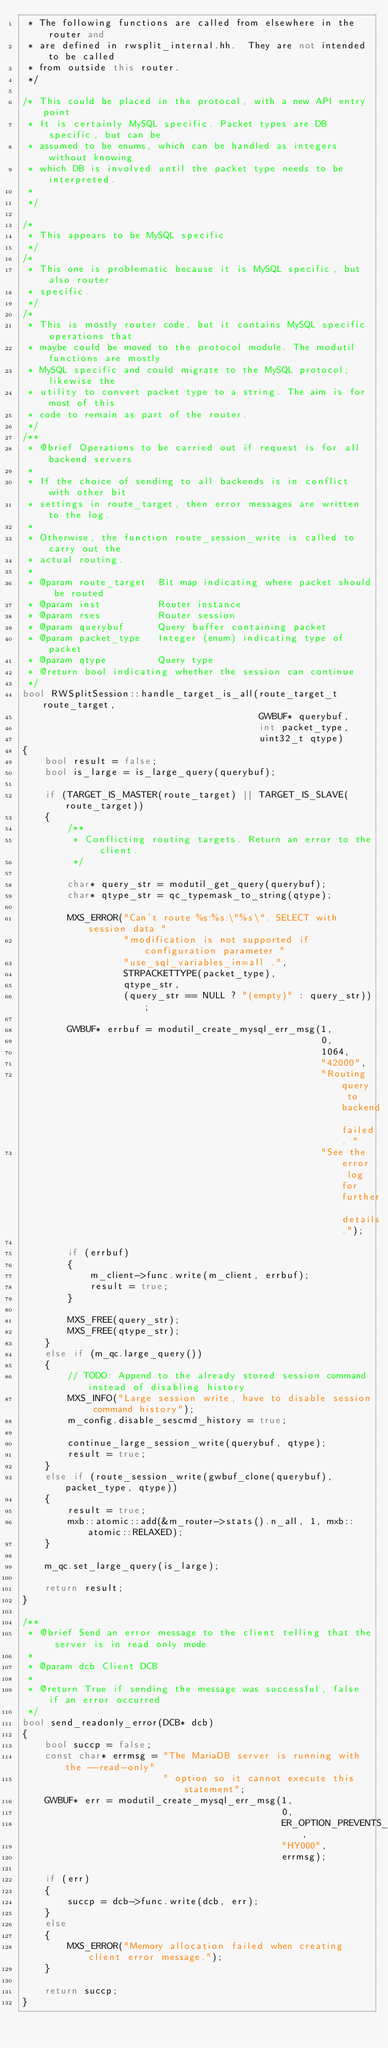<code> <loc_0><loc_0><loc_500><loc_500><_C++_> * The following functions are called from elsewhere in the router and
 * are defined in rwsplit_internal.hh.  They are not intended to be called
 * from outside this router.
 */

/* This could be placed in the protocol, with a new API entry point
 * It is certainly MySQL specific. Packet types are DB specific, but can be
 * assumed to be enums, which can be handled as integers without knowing
 * which DB is involved until the packet type needs to be interpreted.
 *
 */

/*
 * This appears to be MySQL specific
 */
/*
 * This one is problematic because it is MySQL specific, but also router
 * specific.
 */
/*
 * This is mostly router code, but it contains MySQL specific operations that
 * maybe could be moved to the protocol module. The modutil functions are mostly
 * MySQL specific and could migrate to the MySQL protocol; likewise the
 * utility to convert packet type to a string. The aim is for most of this
 * code to remain as part of the router.
 */
/**
 * @brief Operations to be carried out if request is for all backend servers
 *
 * If the choice of sending to all backends is in conflict with other bit
 * settings in route_target, then error messages are written to the log.
 *
 * Otherwise, the function route_session_write is called to carry out the
 * actual routing.
 *
 * @param route_target  Bit map indicating where packet should be routed
 * @param inst          Router instance
 * @param rses          Router session
 * @param querybuf      Query buffer containing packet
 * @param packet_type   Integer (enum) indicating type of packet
 * @param qtype         Query type
 * @return bool indicating whether the session can continue
 */
bool RWSplitSession::handle_target_is_all(route_target_t route_target,
                                          GWBUF* querybuf,
                                          int packet_type,
                                          uint32_t qtype)
{
    bool result = false;
    bool is_large = is_large_query(querybuf);

    if (TARGET_IS_MASTER(route_target) || TARGET_IS_SLAVE(route_target))
    {
        /**
         * Conflicting routing targets. Return an error to the client.
         */

        char* query_str = modutil_get_query(querybuf);
        char* qtype_str = qc_typemask_to_string(qtype);

        MXS_ERROR("Can't route %s:%s:\"%s\". SELECT with session data "
                  "modification is not supported if configuration parameter "
                  "use_sql_variables_in=all .",
                  STRPACKETTYPE(packet_type),
                  qtype_str,
                  (query_str == NULL ? "(empty)" : query_str));

        GWBUF* errbuf = modutil_create_mysql_err_msg(1,
                                                     0,
                                                     1064,
                                                     "42000",
                                                     "Routing query to backend failed. "
                                                     "See the error log for further details.");

        if (errbuf)
        {
            m_client->func.write(m_client, errbuf);
            result = true;
        }

        MXS_FREE(query_str);
        MXS_FREE(qtype_str);
    }
    else if (m_qc.large_query())
    {
        // TODO: Append to the already stored session command instead of disabling history
        MXS_INFO("Large session write, have to disable session command history");
        m_config.disable_sescmd_history = true;

        continue_large_session_write(querybuf, qtype);
        result = true;
    }
    else if (route_session_write(gwbuf_clone(querybuf), packet_type, qtype))
    {
        result = true;
        mxb::atomic::add(&m_router->stats().n_all, 1, mxb::atomic::RELAXED);
    }

    m_qc.set_large_query(is_large);

    return result;
}

/**
 * @brief Send an error message to the client telling that the server is in read only mode
 *
 * @param dcb Client DCB
 *
 * @return True if sending the message was successful, false if an error occurred
 */
bool send_readonly_error(DCB* dcb)
{
    bool succp = false;
    const char* errmsg = "The MariaDB server is running with the --read-only"
                         " option so it cannot execute this statement";
    GWBUF* err = modutil_create_mysql_err_msg(1,
                                              0,
                                              ER_OPTION_PREVENTS_STATEMENT,
                                              "HY000",
                                              errmsg);

    if (err)
    {
        succp = dcb->func.write(dcb, err);
    }
    else
    {
        MXS_ERROR("Memory allocation failed when creating client error message.");
    }

    return succp;
}
</code> 